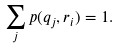Convert formula to latex. <formula><loc_0><loc_0><loc_500><loc_500>\sum _ { j } p ( q _ { j } , r _ { i } ) = 1 .</formula> 